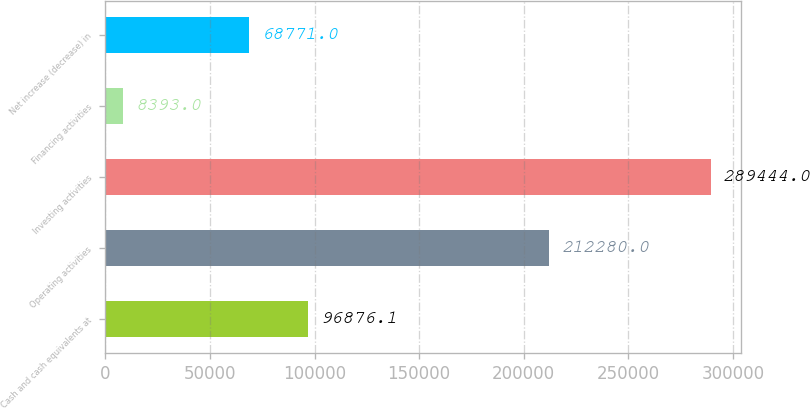<chart> <loc_0><loc_0><loc_500><loc_500><bar_chart><fcel>Cash and cash equivalents at<fcel>Operating activities<fcel>Investing activities<fcel>Financing activities<fcel>Net increase (decrease) in<nl><fcel>96876.1<fcel>212280<fcel>289444<fcel>8393<fcel>68771<nl></chart> 